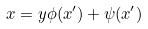Convert formula to latex. <formula><loc_0><loc_0><loc_500><loc_500>x = y \phi ( x ^ { \prime } ) + \psi ( x ^ { \prime } )</formula> 